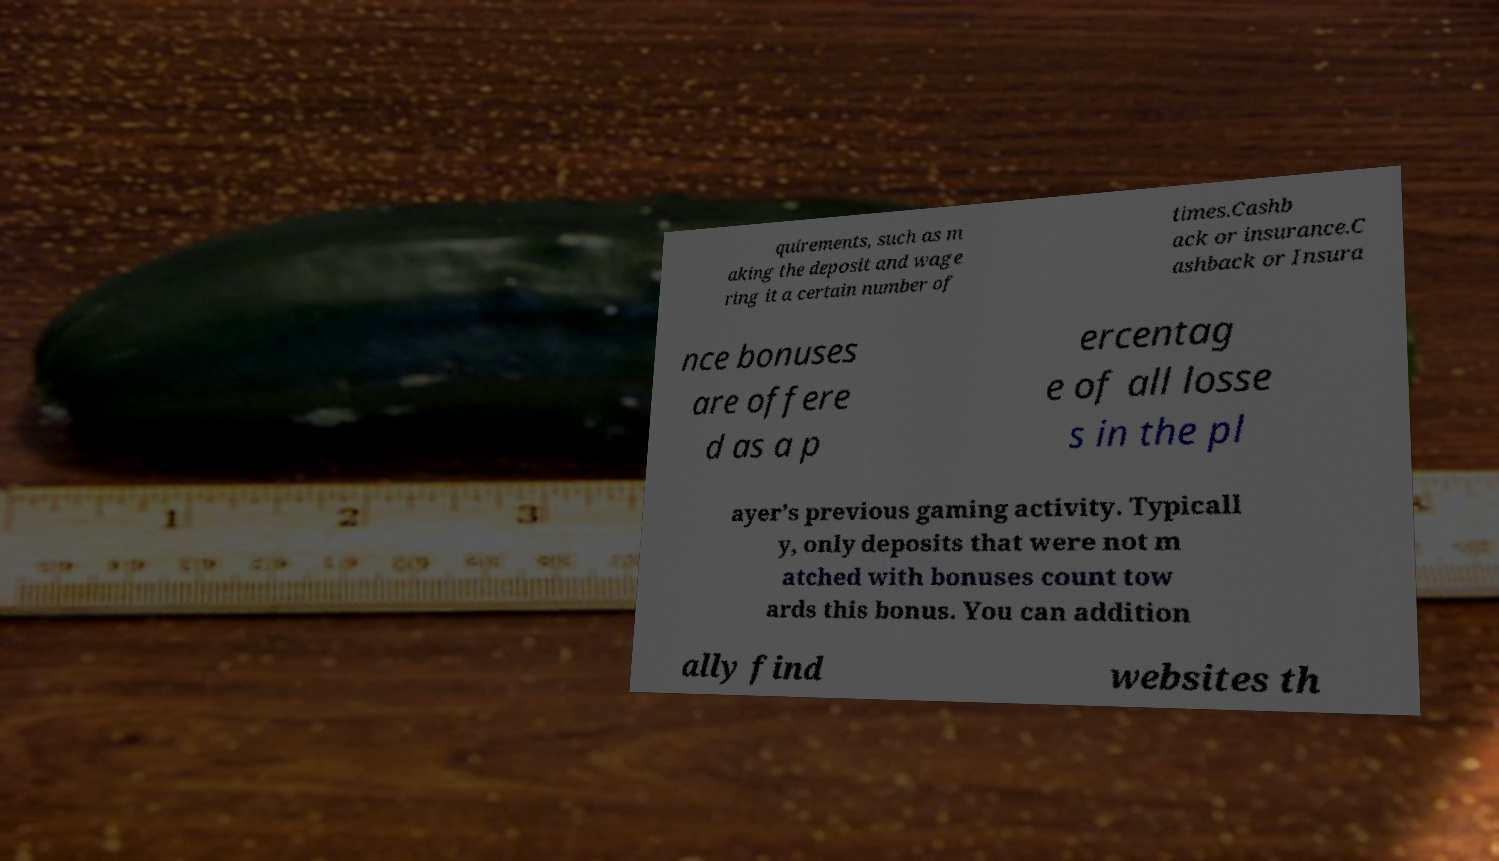Please read and relay the text visible in this image. What does it say? quirements, such as m aking the deposit and wage ring it a certain number of times.Cashb ack or insurance.C ashback or Insura nce bonuses are offere d as a p ercentag e of all losse s in the pl ayer’s previous gaming activity. Typicall y, only deposits that were not m atched with bonuses count tow ards this bonus. You can addition ally find websites th 